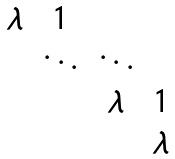Convert formula to latex. <formula><loc_0><loc_0><loc_500><loc_500>\begin{matrix} \lambda & 1 \\ & \ddots & \ddots \\ & & \lambda & 1 \\ & & & \lambda \end{matrix}</formula> 